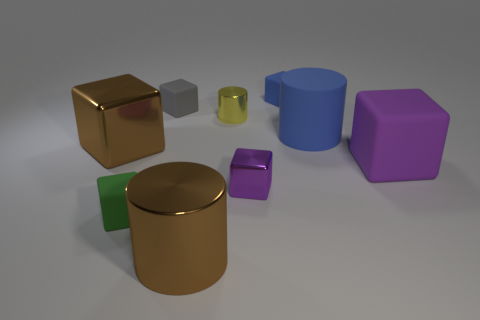Subtract all tiny green matte blocks. How many blocks are left? 5 Subtract 3 blocks. How many blocks are left? 3 Subtract all blue blocks. How many blocks are left? 5 Subtract all brown blocks. Subtract all brown spheres. How many blocks are left? 5 Subtract all cylinders. How many objects are left? 6 Add 2 yellow things. How many yellow things exist? 3 Subtract 0 brown balls. How many objects are left? 9 Subtract all metal objects. Subtract all matte objects. How many objects are left? 0 Add 7 big blue rubber cylinders. How many big blue rubber cylinders are left? 8 